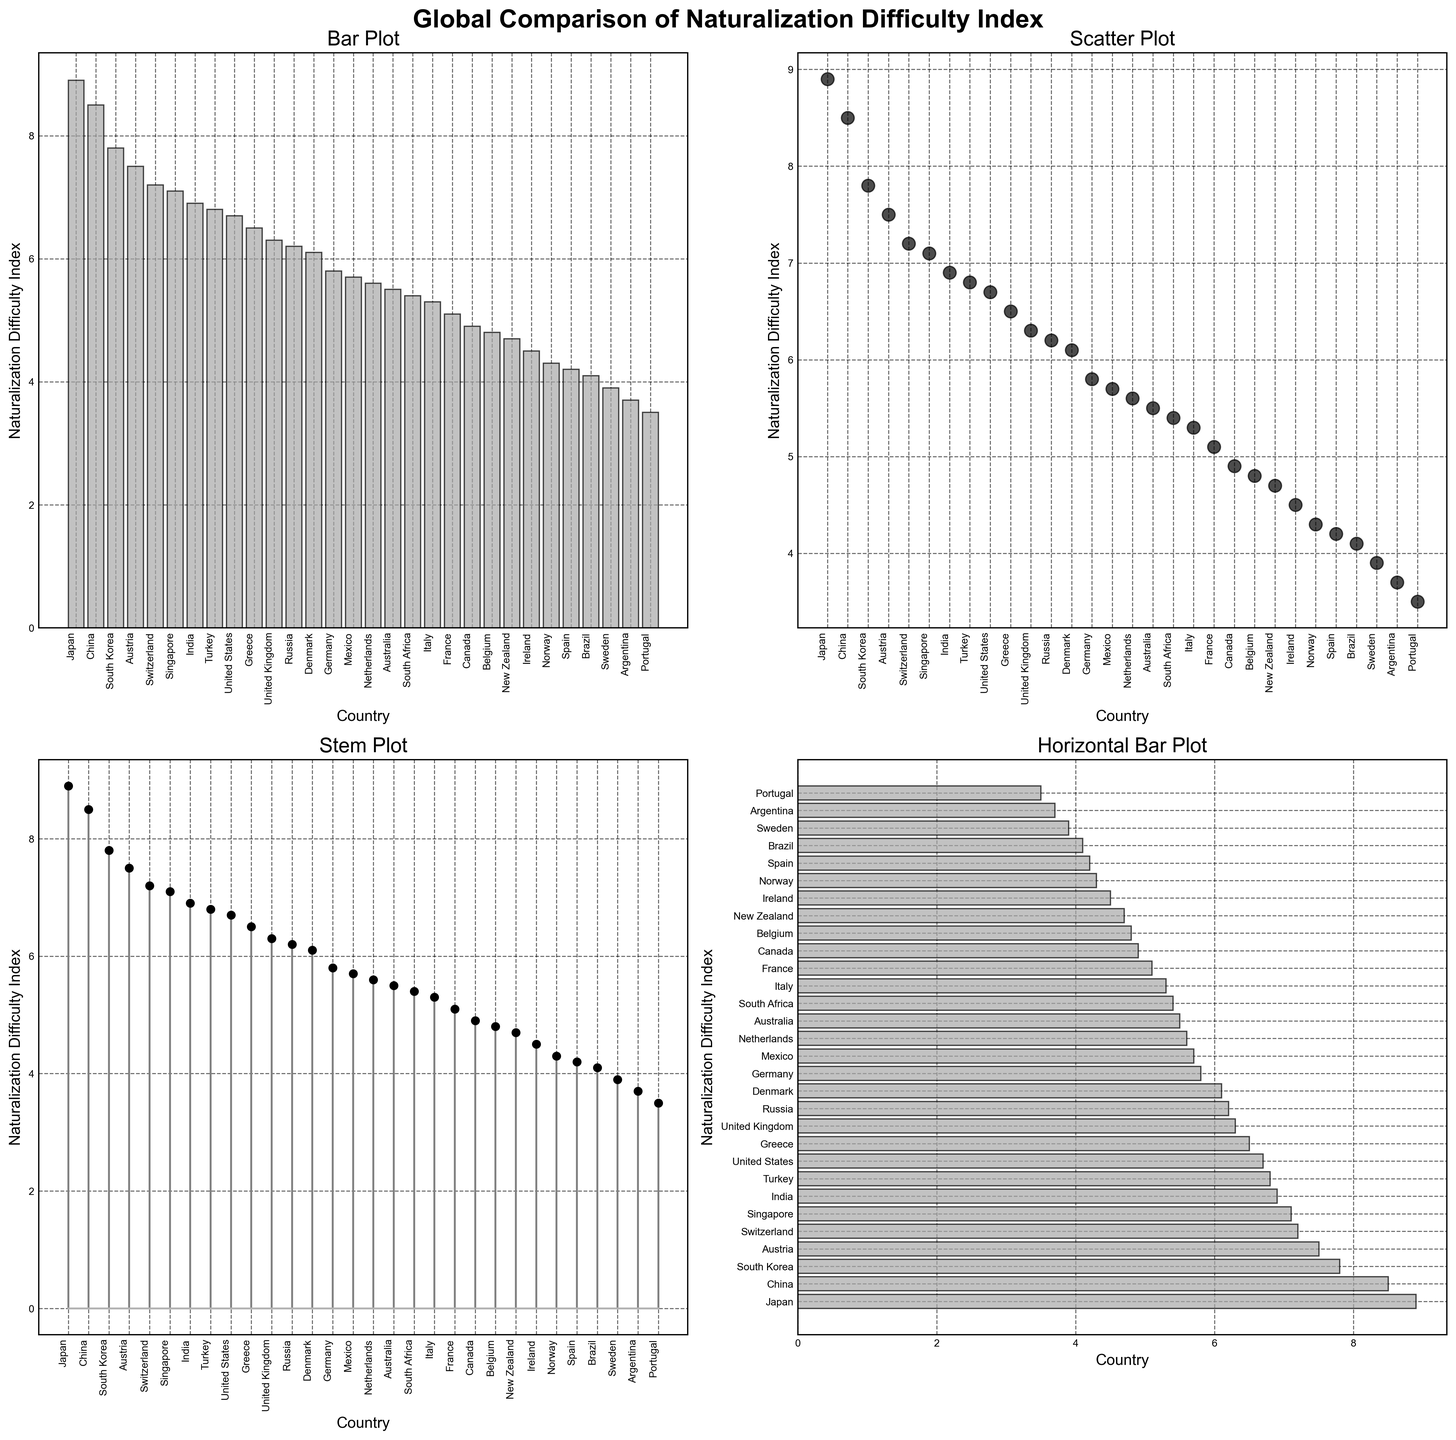Which country has the highest Naturalization Difficulty Index? The rendered figure shows the bar, scatter, stem, and horizontal bar plots of the Naturalization Difficulty Index for various countries. The highest bar/marker/line length aligns with Japan.
Answer: Japan Which country has the lowest Naturalization Difficulty Index? The rendered figure's bar, scatter, stem, and horizontal bar plots indicate that Argentina has the shortest bar/marker/line length, marking it with the lowest index.
Answer: Argentina What is the difference in Naturalization Difficulty Index between Japan and Portugal? From the figure, Japan's index is 8.9 and Portugal's index is 3.5. The difference is calculated as 8.9 - 3.5 = 5.4.
Answer: 5.4 Which countries have an index greater than 7? Observing the charts, the countries with indices above 7 are Japan, South Korea, Switzerland, Singapore, China, and Austria.
Answer: Japan, South Korea, Switzerland, Singapore, China, Austria Are there more countries with an index less than 5 or greater than 5? Counting the countries in the figure, there are 10 countries with indices below 5 and 20 countries with indices above 5. Thus, there are fewer countries with an index less than 5 compared to those greater than 5.
Answer: Greater than 5 What is the average Naturalization Difficulty Index of European countries in the figure? European countries in the figure are Portugal, Spain, France, Germany, United Kingdom, Norway, Denmark, Netherlands, Belgium, Switzerland, Italy, Greece, Ireland, Austria. Summing their indices (3.5 + 4.2 + 5.1 + 5.8 + 6.3 + 4.3 + 6.1 + 5.6 + 4.8 + 7.2 + 5.3 + 6.5 + 4.5 + 7.5 = 76.7) and dividing by the count (14), the average is 76.7 / 14 ≈ 5.5.
Answer: 5.5 Which countries have an index exactly equal to 6.1? Referring to the figure, Denmark is the country with an index exactly equal to 6.1.
Answer: Denmark How does Brazil's index compare to Canada's? According to the plot, Brazil's index is 4.1, while Canada's index is 4.9. 4.1 is less than 4.9, so Brazil has a lower index than Canada.
Answer: Less than What is the sum of the indices for the top 5 countries with the highest Naturalization Difficulty Index? From the rendered figure, the top 5 countries by index are Japan, China, South Korea, Austria, and Switzerland with indices 8.9, 8.5, 7.8, 7.5, and 7.2 respectively. Summing these: 8.9 + 8.5 + 7.8 + 7.5 + 7.2 = 39.9.
Answer: 39.9 